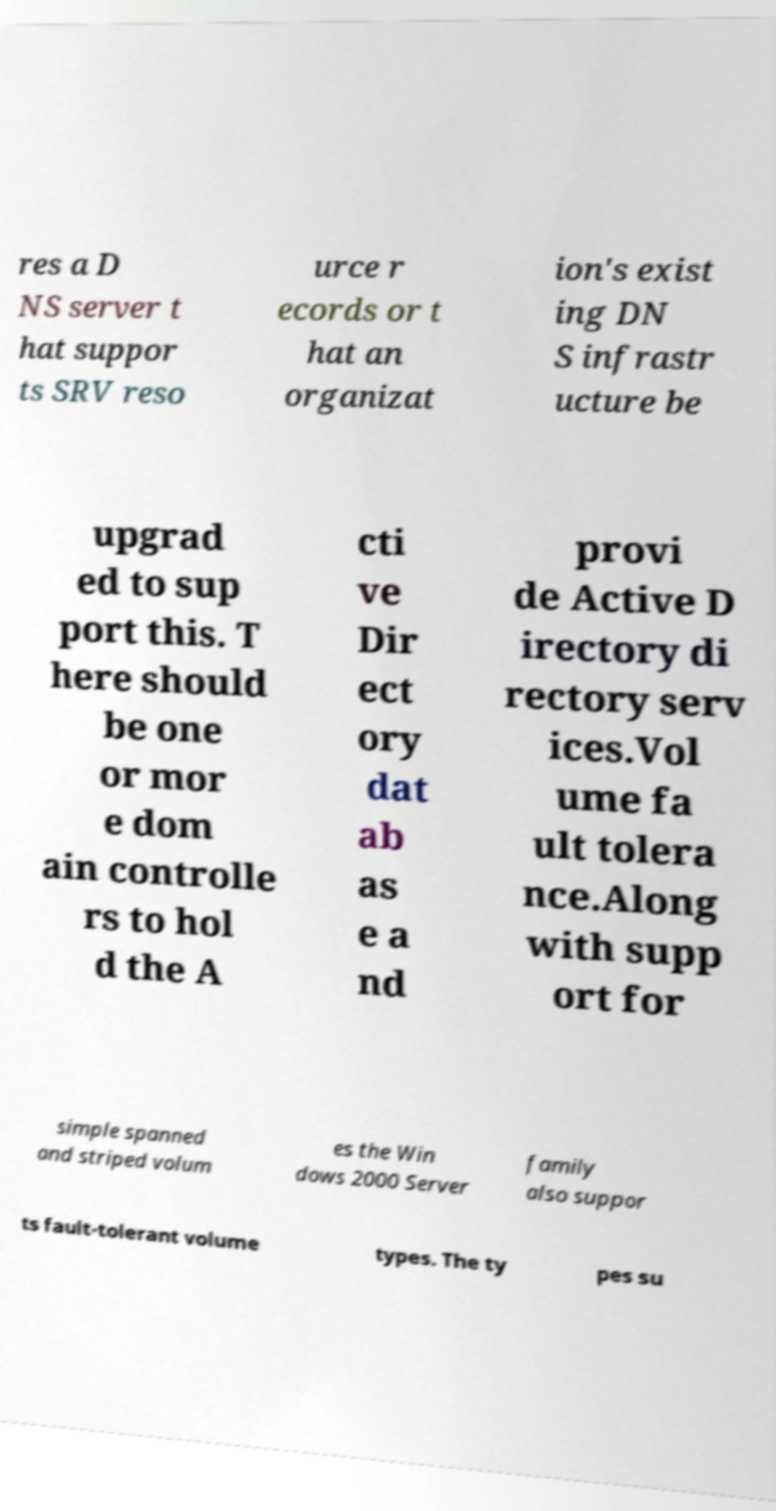Can you accurately transcribe the text from the provided image for me? res a D NS server t hat suppor ts SRV reso urce r ecords or t hat an organizat ion's exist ing DN S infrastr ucture be upgrad ed to sup port this. T here should be one or mor e dom ain controlle rs to hol d the A cti ve Dir ect ory dat ab as e a nd provi de Active D irectory di rectory serv ices.Vol ume fa ult tolera nce.Along with supp ort for simple spanned and striped volum es the Win dows 2000 Server family also suppor ts fault-tolerant volume types. The ty pes su 